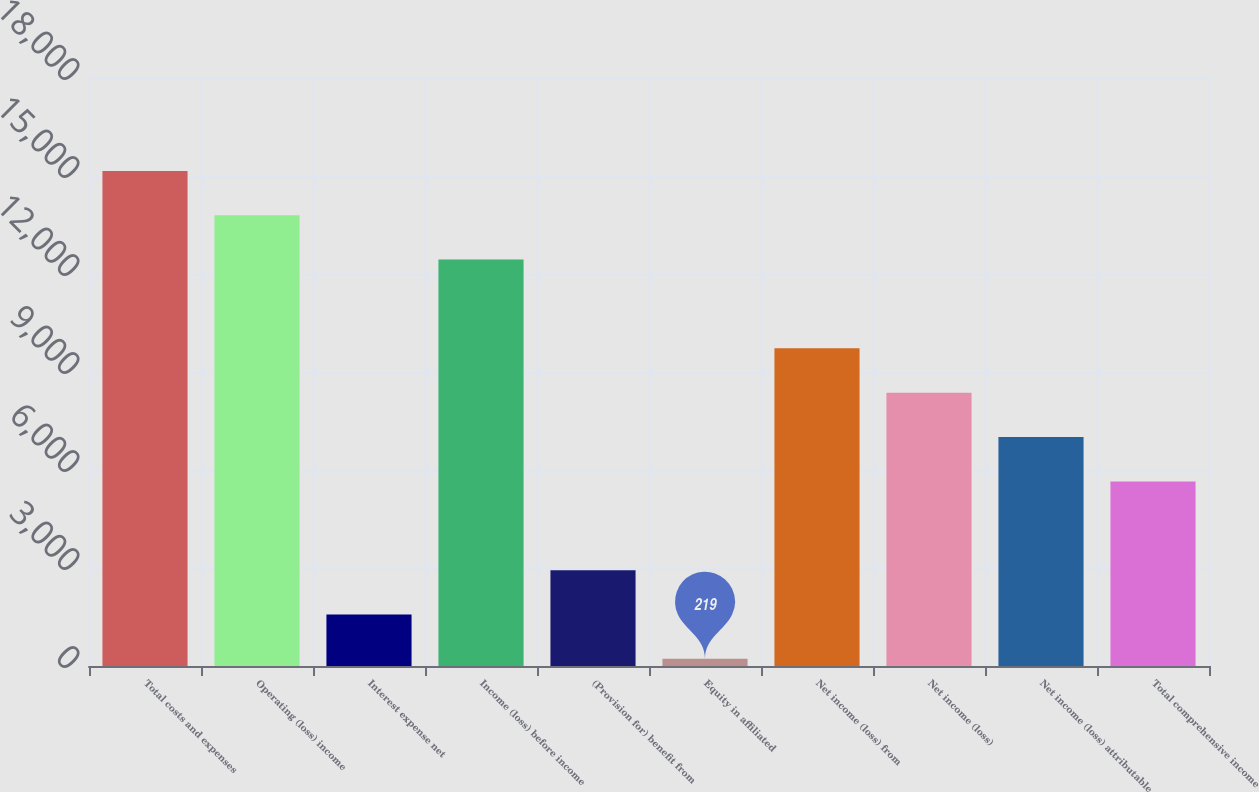Convert chart. <chart><loc_0><loc_0><loc_500><loc_500><bar_chart><fcel>Total costs and expenses<fcel>Operating (loss) income<fcel>Interest expense net<fcel>Income (loss) before income<fcel>(Provision for) benefit from<fcel>Equity in affiliated<fcel>Net income (loss) from<fcel>Net income (loss)<fcel>Net income (loss) attributable<fcel>Total comprehensive income<nl><fcel>15155.9<fcel>13798<fcel>1576.9<fcel>12440.1<fcel>2934.8<fcel>219<fcel>9724.3<fcel>8366.4<fcel>7008.5<fcel>5650.6<nl></chart> 